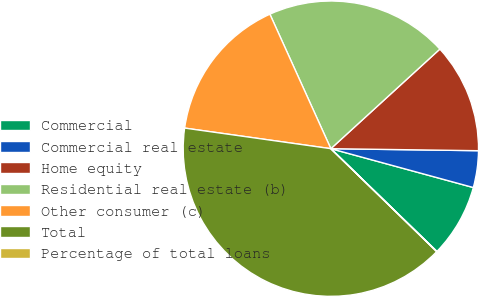<chart> <loc_0><loc_0><loc_500><loc_500><pie_chart><fcel>Commercial<fcel>Commercial real estate<fcel>Home equity<fcel>Residential real estate (b)<fcel>Other consumer (c)<fcel>Total<fcel>Percentage of total loans<nl><fcel>8.01%<fcel>4.02%<fcel>12.0%<fcel>19.99%<fcel>16.0%<fcel>39.95%<fcel>0.03%<nl></chart> 